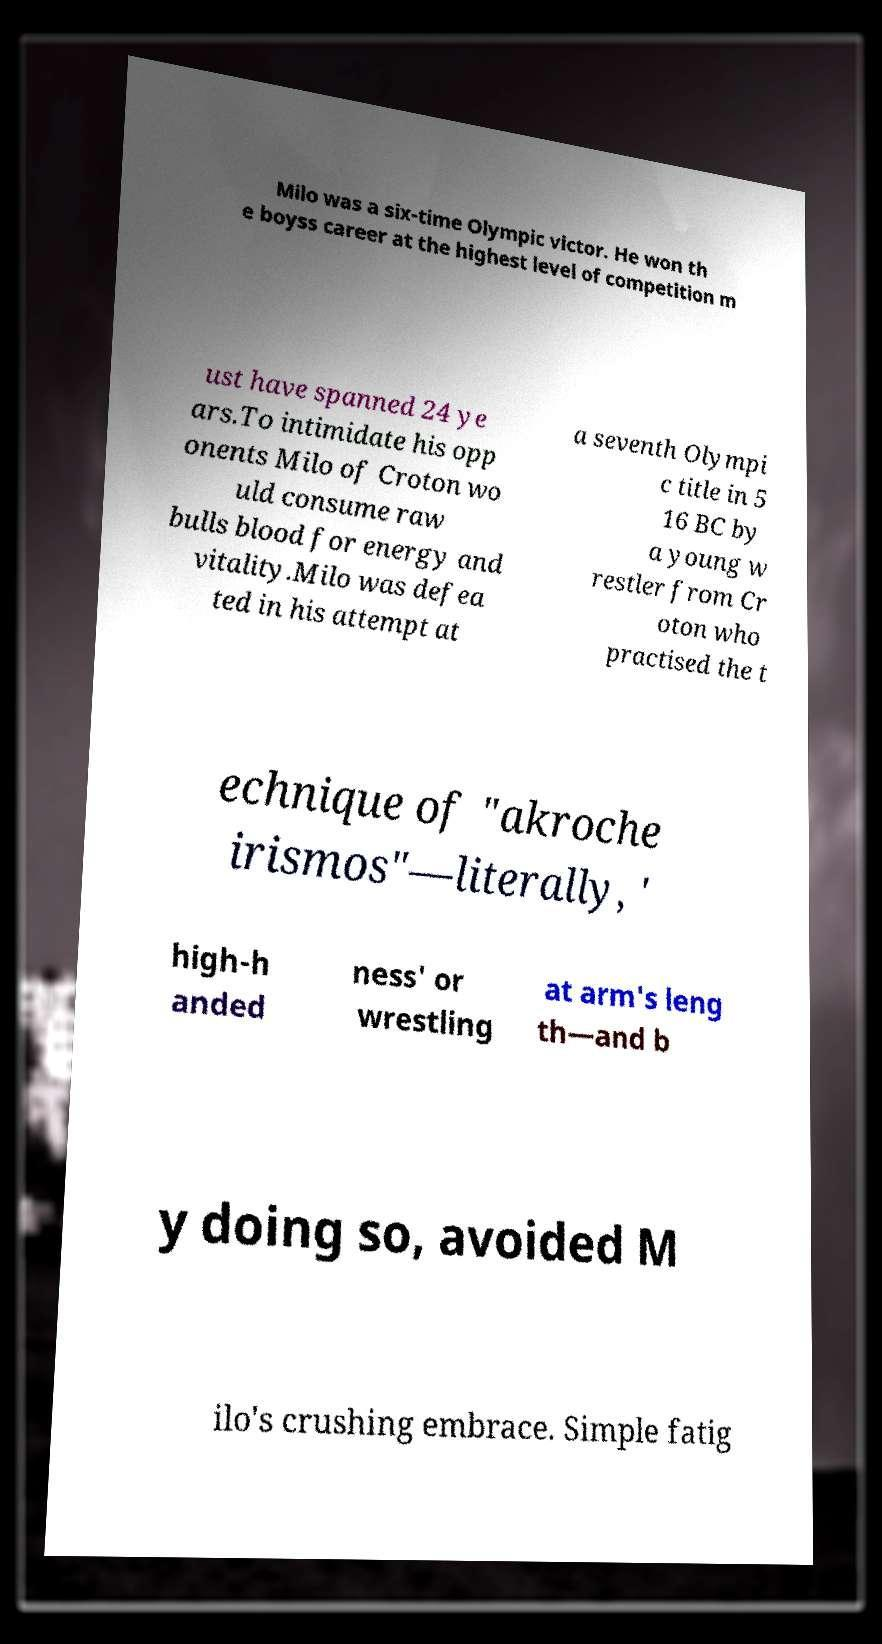Could you assist in decoding the text presented in this image and type it out clearly? Milo was a six-time Olympic victor. He won th e boyss career at the highest level of competition m ust have spanned 24 ye ars.To intimidate his opp onents Milo of Croton wo uld consume raw bulls blood for energy and vitality.Milo was defea ted in his attempt at a seventh Olympi c title in 5 16 BC by a young w restler from Cr oton who practised the t echnique of "akroche irismos"—literally, ' high-h anded ness' or wrestling at arm's leng th—and b y doing so, avoided M ilo's crushing embrace. Simple fatig 